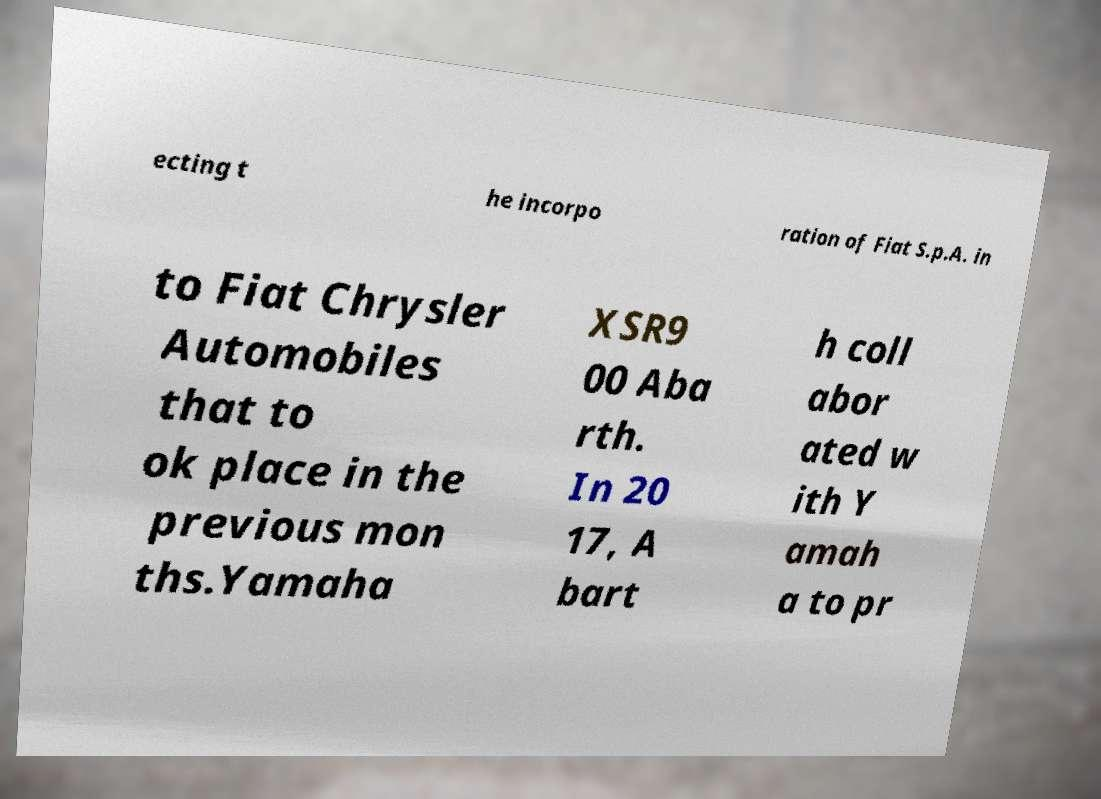Could you extract and type out the text from this image? ecting t he incorpo ration of Fiat S.p.A. in to Fiat Chrysler Automobiles that to ok place in the previous mon ths.Yamaha XSR9 00 Aba rth. In 20 17, A bart h coll abor ated w ith Y amah a to pr 